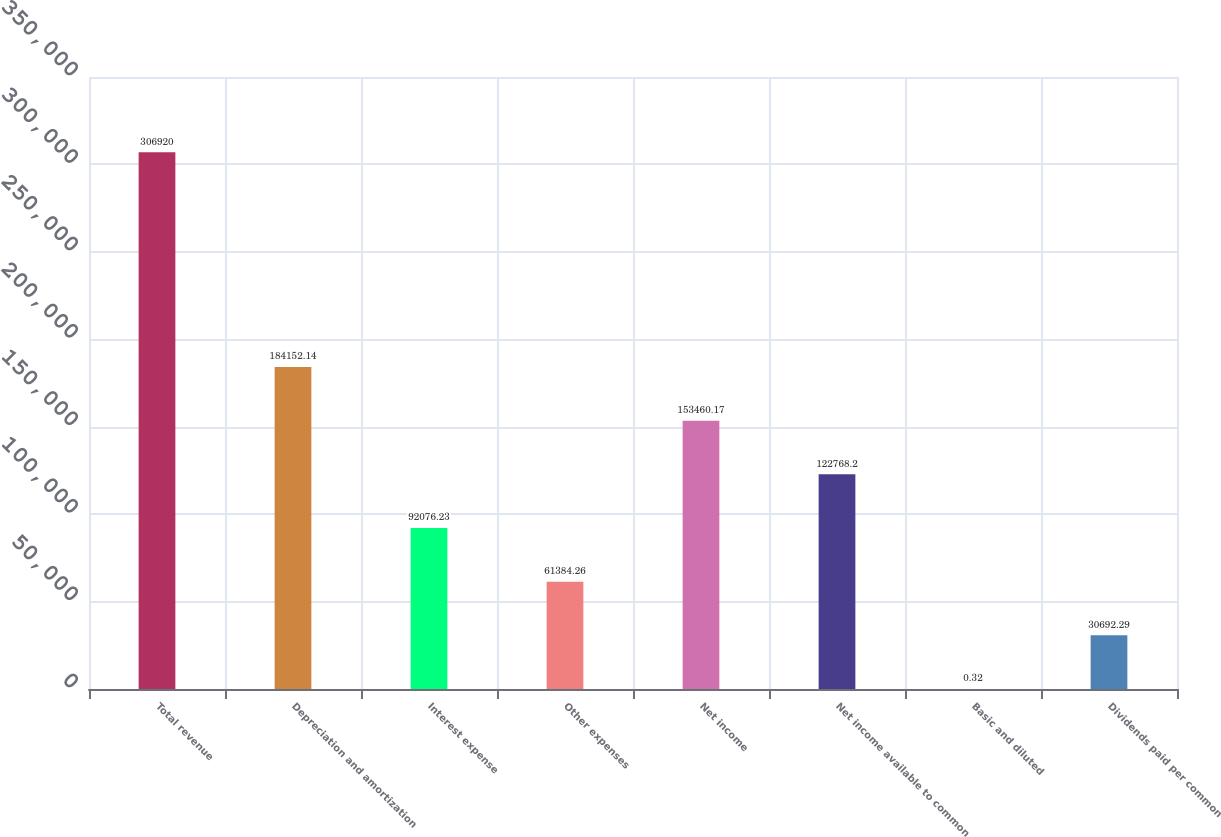Convert chart. <chart><loc_0><loc_0><loc_500><loc_500><bar_chart><fcel>Total revenue<fcel>Depreciation and amortization<fcel>Interest expense<fcel>Other expenses<fcel>Net income<fcel>Net income available to common<fcel>Basic and diluted<fcel>Dividends paid per common<nl><fcel>306920<fcel>184152<fcel>92076.2<fcel>61384.3<fcel>153460<fcel>122768<fcel>0.32<fcel>30692.3<nl></chart> 